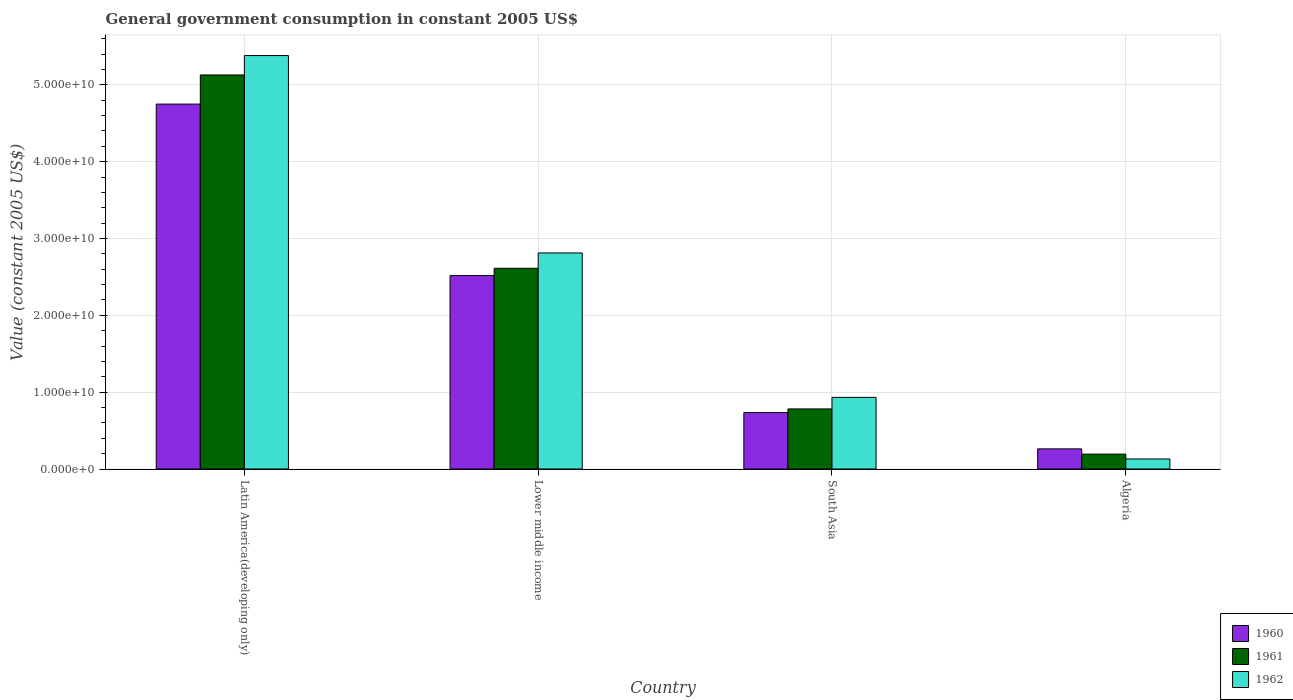Are the number of bars on each tick of the X-axis equal?
Your response must be concise. Yes. How many bars are there on the 4th tick from the left?
Your answer should be very brief. 3. What is the label of the 1st group of bars from the left?
Ensure brevity in your answer.  Latin America(developing only). What is the government conusmption in 1961 in Latin America(developing only)?
Ensure brevity in your answer.  5.13e+1. Across all countries, what is the maximum government conusmption in 1961?
Your answer should be compact. 5.13e+1. Across all countries, what is the minimum government conusmption in 1960?
Keep it short and to the point. 2.62e+09. In which country was the government conusmption in 1962 maximum?
Keep it short and to the point. Latin America(developing only). In which country was the government conusmption in 1960 minimum?
Your response must be concise. Algeria. What is the total government conusmption in 1962 in the graph?
Keep it short and to the point. 9.26e+1. What is the difference between the government conusmption in 1962 in Latin America(developing only) and that in Lower middle income?
Your answer should be very brief. 2.57e+1. What is the difference between the government conusmption in 1960 in Algeria and the government conusmption in 1961 in Latin America(developing only)?
Keep it short and to the point. -4.87e+1. What is the average government conusmption in 1961 per country?
Provide a short and direct response. 2.18e+1. What is the difference between the government conusmption of/in 1961 and government conusmption of/in 1962 in Latin America(developing only)?
Provide a succinct answer. -2.53e+09. In how many countries, is the government conusmption in 1962 greater than 52000000000 US$?
Your answer should be very brief. 1. What is the ratio of the government conusmption in 1962 in Algeria to that in South Asia?
Your answer should be very brief. 0.14. What is the difference between the highest and the second highest government conusmption in 1962?
Give a very brief answer. 2.57e+1. What is the difference between the highest and the lowest government conusmption in 1961?
Your response must be concise. 4.93e+1. Is the sum of the government conusmption in 1960 in Latin America(developing only) and Lower middle income greater than the maximum government conusmption in 1961 across all countries?
Your answer should be compact. Yes. What does the 3rd bar from the left in South Asia represents?
Your response must be concise. 1962. Is it the case that in every country, the sum of the government conusmption in 1962 and government conusmption in 1961 is greater than the government conusmption in 1960?
Make the answer very short. Yes. How many bars are there?
Your response must be concise. 12. How many countries are there in the graph?
Give a very brief answer. 4. Are the values on the major ticks of Y-axis written in scientific E-notation?
Make the answer very short. Yes. Does the graph contain any zero values?
Give a very brief answer. No. Does the graph contain grids?
Offer a very short reply. Yes. Where does the legend appear in the graph?
Provide a succinct answer. Bottom right. How many legend labels are there?
Your response must be concise. 3. What is the title of the graph?
Your answer should be very brief. General government consumption in constant 2005 US$. Does "1971" appear as one of the legend labels in the graph?
Keep it short and to the point. No. What is the label or title of the Y-axis?
Provide a succinct answer. Value (constant 2005 US$). What is the Value (constant 2005 US$) in 1960 in Latin America(developing only)?
Your response must be concise. 4.75e+1. What is the Value (constant 2005 US$) in 1961 in Latin America(developing only)?
Make the answer very short. 5.13e+1. What is the Value (constant 2005 US$) in 1962 in Latin America(developing only)?
Provide a succinct answer. 5.38e+1. What is the Value (constant 2005 US$) in 1960 in Lower middle income?
Give a very brief answer. 2.52e+1. What is the Value (constant 2005 US$) in 1961 in Lower middle income?
Your response must be concise. 2.61e+1. What is the Value (constant 2005 US$) in 1962 in Lower middle income?
Offer a terse response. 2.81e+1. What is the Value (constant 2005 US$) of 1960 in South Asia?
Give a very brief answer. 7.34e+09. What is the Value (constant 2005 US$) in 1961 in South Asia?
Your response must be concise. 7.82e+09. What is the Value (constant 2005 US$) in 1962 in South Asia?
Ensure brevity in your answer.  9.32e+09. What is the Value (constant 2005 US$) in 1960 in Algeria?
Offer a very short reply. 2.62e+09. What is the Value (constant 2005 US$) of 1961 in Algeria?
Offer a terse response. 1.94e+09. What is the Value (constant 2005 US$) in 1962 in Algeria?
Provide a succinct answer. 1.31e+09. Across all countries, what is the maximum Value (constant 2005 US$) of 1960?
Offer a very short reply. 4.75e+1. Across all countries, what is the maximum Value (constant 2005 US$) of 1961?
Offer a very short reply. 5.13e+1. Across all countries, what is the maximum Value (constant 2005 US$) in 1962?
Provide a succinct answer. 5.38e+1. Across all countries, what is the minimum Value (constant 2005 US$) in 1960?
Offer a terse response. 2.62e+09. Across all countries, what is the minimum Value (constant 2005 US$) in 1961?
Offer a very short reply. 1.94e+09. Across all countries, what is the minimum Value (constant 2005 US$) of 1962?
Your answer should be compact. 1.31e+09. What is the total Value (constant 2005 US$) in 1960 in the graph?
Offer a terse response. 8.26e+1. What is the total Value (constant 2005 US$) in 1961 in the graph?
Provide a succinct answer. 8.72e+1. What is the total Value (constant 2005 US$) of 1962 in the graph?
Your answer should be very brief. 9.26e+1. What is the difference between the Value (constant 2005 US$) of 1960 in Latin America(developing only) and that in Lower middle income?
Offer a very short reply. 2.23e+1. What is the difference between the Value (constant 2005 US$) in 1961 in Latin America(developing only) and that in Lower middle income?
Provide a succinct answer. 2.52e+1. What is the difference between the Value (constant 2005 US$) of 1962 in Latin America(developing only) and that in Lower middle income?
Provide a succinct answer. 2.57e+1. What is the difference between the Value (constant 2005 US$) in 1960 in Latin America(developing only) and that in South Asia?
Make the answer very short. 4.01e+1. What is the difference between the Value (constant 2005 US$) in 1961 in Latin America(developing only) and that in South Asia?
Provide a short and direct response. 4.35e+1. What is the difference between the Value (constant 2005 US$) in 1962 in Latin America(developing only) and that in South Asia?
Provide a short and direct response. 4.45e+1. What is the difference between the Value (constant 2005 US$) of 1960 in Latin America(developing only) and that in Algeria?
Provide a succinct answer. 4.49e+1. What is the difference between the Value (constant 2005 US$) of 1961 in Latin America(developing only) and that in Algeria?
Ensure brevity in your answer.  4.93e+1. What is the difference between the Value (constant 2005 US$) in 1962 in Latin America(developing only) and that in Algeria?
Your answer should be compact. 5.25e+1. What is the difference between the Value (constant 2005 US$) of 1960 in Lower middle income and that in South Asia?
Provide a succinct answer. 1.78e+1. What is the difference between the Value (constant 2005 US$) in 1961 in Lower middle income and that in South Asia?
Your answer should be very brief. 1.83e+1. What is the difference between the Value (constant 2005 US$) of 1962 in Lower middle income and that in South Asia?
Offer a terse response. 1.88e+1. What is the difference between the Value (constant 2005 US$) of 1960 in Lower middle income and that in Algeria?
Provide a succinct answer. 2.26e+1. What is the difference between the Value (constant 2005 US$) of 1961 in Lower middle income and that in Algeria?
Offer a very short reply. 2.42e+1. What is the difference between the Value (constant 2005 US$) in 1962 in Lower middle income and that in Algeria?
Provide a succinct answer. 2.68e+1. What is the difference between the Value (constant 2005 US$) of 1960 in South Asia and that in Algeria?
Offer a very short reply. 4.72e+09. What is the difference between the Value (constant 2005 US$) in 1961 in South Asia and that in Algeria?
Offer a very short reply. 5.88e+09. What is the difference between the Value (constant 2005 US$) in 1962 in South Asia and that in Algeria?
Provide a succinct answer. 8.01e+09. What is the difference between the Value (constant 2005 US$) in 1960 in Latin America(developing only) and the Value (constant 2005 US$) in 1961 in Lower middle income?
Your response must be concise. 2.14e+1. What is the difference between the Value (constant 2005 US$) of 1960 in Latin America(developing only) and the Value (constant 2005 US$) of 1962 in Lower middle income?
Your response must be concise. 1.94e+1. What is the difference between the Value (constant 2005 US$) in 1961 in Latin America(developing only) and the Value (constant 2005 US$) in 1962 in Lower middle income?
Provide a short and direct response. 2.32e+1. What is the difference between the Value (constant 2005 US$) in 1960 in Latin America(developing only) and the Value (constant 2005 US$) in 1961 in South Asia?
Give a very brief answer. 3.97e+1. What is the difference between the Value (constant 2005 US$) of 1960 in Latin America(developing only) and the Value (constant 2005 US$) of 1962 in South Asia?
Your answer should be very brief. 3.82e+1. What is the difference between the Value (constant 2005 US$) of 1961 in Latin America(developing only) and the Value (constant 2005 US$) of 1962 in South Asia?
Provide a succinct answer. 4.20e+1. What is the difference between the Value (constant 2005 US$) of 1960 in Latin America(developing only) and the Value (constant 2005 US$) of 1961 in Algeria?
Offer a very short reply. 4.56e+1. What is the difference between the Value (constant 2005 US$) in 1960 in Latin America(developing only) and the Value (constant 2005 US$) in 1962 in Algeria?
Your answer should be very brief. 4.62e+1. What is the difference between the Value (constant 2005 US$) of 1961 in Latin America(developing only) and the Value (constant 2005 US$) of 1962 in Algeria?
Offer a terse response. 5.00e+1. What is the difference between the Value (constant 2005 US$) of 1960 in Lower middle income and the Value (constant 2005 US$) of 1961 in South Asia?
Offer a terse response. 1.74e+1. What is the difference between the Value (constant 2005 US$) of 1960 in Lower middle income and the Value (constant 2005 US$) of 1962 in South Asia?
Ensure brevity in your answer.  1.59e+1. What is the difference between the Value (constant 2005 US$) of 1961 in Lower middle income and the Value (constant 2005 US$) of 1962 in South Asia?
Your answer should be compact. 1.68e+1. What is the difference between the Value (constant 2005 US$) in 1960 in Lower middle income and the Value (constant 2005 US$) in 1961 in Algeria?
Give a very brief answer. 2.32e+1. What is the difference between the Value (constant 2005 US$) in 1960 in Lower middle income and the Value (constant 2005 US$) in 1962 in Algeria?
Provide a succinct answer. 2.39e+1. What is the difference between the Value (constant 2005 US$) of 1961 in Lower middle income and the Value (constant 2005 US$) of 1962 in Algeria?
Make the answer very short. 2.48e+1. What is the difference between the Value (constant 2005 US$) of 1960 in South Asia and the Value (constant 2005 US$) of 1961 in Algeria?
Offer a very short reply. 5.41e+09. What is the difference between the Value (constant 2005 US$) of 1960 in South Asia and the Value (constant 2005 US$) of 1962 in Algeria?
Your answer should be very brief. 6.03e+09. What is the difference between the Value (constant 2005 US$) of 1961 in South Asia and the Value (constant 2005 US$) of 1962 in Algeria?
Provide a succinct answer. 6.51e+09. What is the average Value (constant 2005 US$) in 1960 per country?
Your response must be concise. 2.07e+1. What is the average Value (constant 2005 US$) in 1961 per country?
Provide a short and direct response. 2.18e+1. What is the average Value (constant 2005 US$) of 1962 per country?
Provide a short and direct response. 2.31e+1. What is the difference between the Value (constant 2005 US$) in 1960 and Value (constant 2005 US$) in 1961 in Latin America(developing only)?
Give a very brief answer. -3.79e+09. What is the difference between the Value (constant 2005 US$) in 1960 and Value (constant 2005 US$) in 1962 in Latin America(developing only)?
Your answer should be very brief. -6.32e+09. What is the difference between the Value (constant 2005 US$) of 1961 and Value (constant 2005 US$) of 1962 in Latin America(developing only)?
Provide a short and direct response. -2.53e+09. What is the difference between the Value (constant 2005 US$) of 1960 and Value (constant 2005 US$) of 1961 in Lower middle income?
Offer a very short reply. -9.46e+08. What is the difference between the Value (constant 2005 US$) of 1960 and Value (constant 2005 US$) of 1962 in Lower middle income?
Keep it short and to the point. -2.95e+09. What is the difference between the Value (constant 2005 US$) of 1961 and Value (constant 2005 US$) of 1962 in Lower middle income?
Keep it short and to the point. -2.00e+09. What is the difference between the Value (constant 2005 US$) of 1960 and Value (constant 2005 US$) of 1961 in South Asia?
Provide a succinct answer. -4.76e+08. What is the difference between the Value (constant 2005 US$) in 1960 and Value (constant 2005 US$) in 1962 in South Asia?
Provide a short and direct response. -1.98e+09. What is the difference between the Value (constant 2005 US$) in 1961 and Value (constant 2005 US$) in 1962 in South Asia?
Offer a terse response. -1.50e+09. What is the difference between the Value (constant 2005 US$) of 1960 and Value (constant 2005 US$) of 1961 in Algeria?
Ensure brevity in your answer.  6.84e+08. What is the difference between the Value (constant 2005 US$) in 1960 and Value (constant 2005 US$) in 1962 in Algeria?
Ensure brevity in your answer.  1.31e+09. What is the difference between the Value (constant 2005 US$) in 1961 and Value (constant 2005 US$) in 1962 in Algeria?
Your response must be concise. 6.27e+08. What is the ratio of the Value (constant 2005 US$) of 1960 in Latin America(developing only) to that in Lower middle income?
Provide a short and direct response. 1.89. What is the ratio of the Value (constant 2005 US$) in 1961 in Latin America(developing only) to that in Lower middle income?
Ensure brevity in your answer.  1.96. What is the ratio of the Value (constant 2005 US$) of 1962 in Latin America(developing only) to that in Lower middle income?
Give a very brief answer. 1.91. What is the ratio of the Value (constant 2005 US$) of 1960 in Latin America(developing only) to that in South Asia?
Offer a terse response. 6.47. What is the ratio of the Value (constant 2005 US$) in 1961 in Latin America(developing only) to that in South Asia?
Give a very brief answer. 6.56. What is the ratio of the Value (constant 2005 US$) in 1962 in Latin America(developing only) to that in South Asia?
Your response must be concise. 5.77. What is the ratio of the Value (constant 2005 US$) in 1960 in Latin America(developing only) to that in Algeria?
Provide a succinct answer. 18.11. What is the ratio of the Value (constant 2005 US$) in 1961 in Latin America(developing only) to that in Algeria?
Your answer should be compact. 26.46. What is the ratio of the Value (constant 2005 US$) of 1962 in Latin America(developing only) to that in Algeria?
Provide a succinct answer. 41.05. What is the ratio of the Value (constant 2005 US$) of 1960 in Lower middle income to that in South Asia?
Offer a very short reply. 3.43. What is the ratio of the Value (constant 2005 US$) of 1961 in Lower middle income to that in South Asia?
Your answer should be very brief. 3.34. What is the ratio of the Value (constant 2005 US$) of 1962 in Lower middle income to that in South Asia?
Provide a succinct answer. 3.02. What is the ratio of the Value (constant 2005 US$) in 1960 in Lower middle income to that in Algeria?
Offer a terse response. 9.6. What is the ratio of the Value (constant 2005 US$) of 1961 in Lower middle income to that in Algeria?
Offer a terse response. 13.48. What is the ratio of the Value (constant 2005 US$) in 1962 in Lower middle income to that in Algeria?
Your answer should be compact. 21.45. What is the ratio of the Value (constant 2005 US$) of 1960 in South Asia to that in Algeria?
Give a very brief answer. 2.8. What is the ratio of the Value (constant 2005 US$) of 1961 in South Asia to that in Algeria?
Ensure brevity in your answer.  4.04. What is the ratio of the Value (constant 2005 US$) in 1962 in South Asia to that in Algeria?
Your answer should be very brief. 7.11. What is the difference between the highest and the second highest Value (constant 2005 US$) of 1960?
Provide a short and direct response. 2.23e+1. What is the difference between the highest and the second highest Value (constant 2005 US$) of 1961?
Give a very brief answer. 2.52e+1. What is the difference between the highest and the second highest Value (constant 2005 US$) in 1962?
Offer a terse response. 2.57e+1. What is the difference between the highest and the lowest Value (constant 2005 US$) of 1960?
Ensure brevity in your answer.  4.49e+1. What is the difference between the highest and the lowest Value (constant 2005 US$) in 1961?
Provide a succinct answer. 4.93e+1. What is the difference between the highest and the lowest Value (constant 2005 US$) of 1962?
Offer a very short reply. 5.25e+1. 